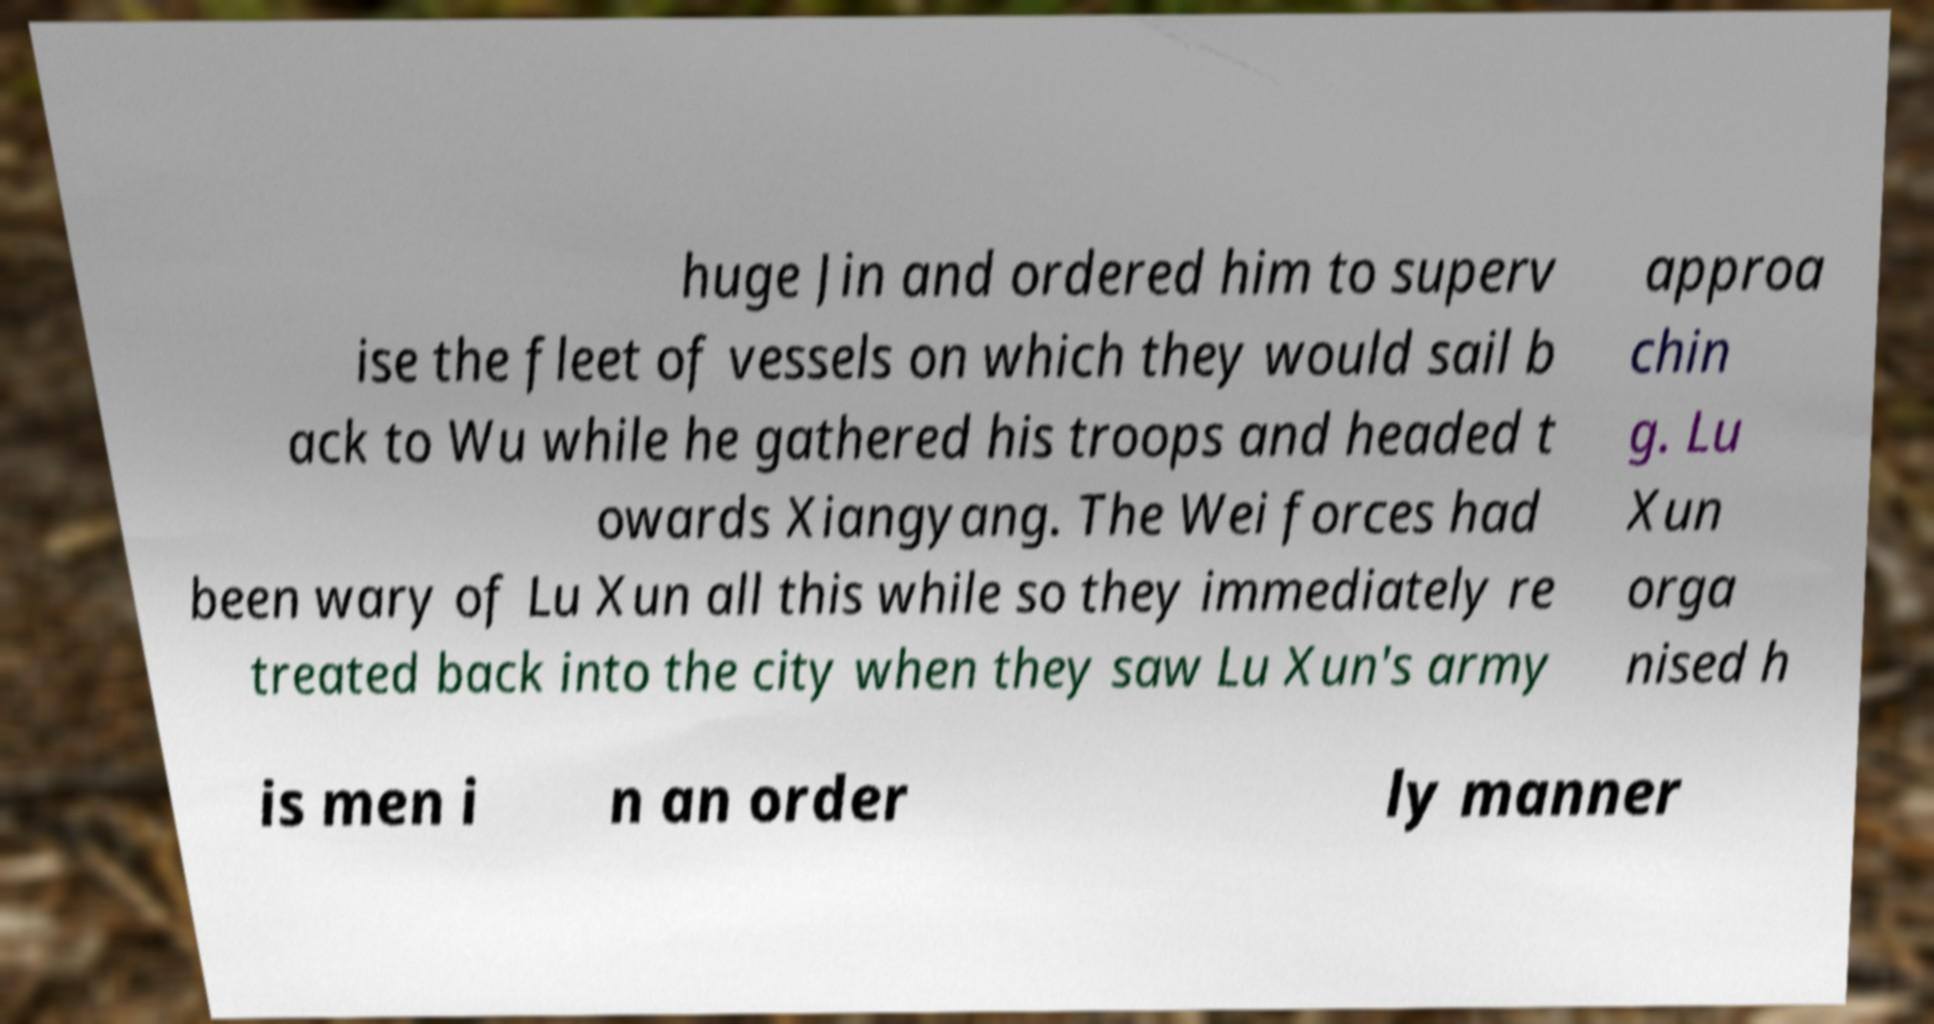Please read and relay the text visible in this image. What does it say? huge Jin and ordered him to superv ise the fleet of vessels on which they would sail b ack to Wu while he gathered his troops and headed t owards Xiangyang. The Wei forces had been wary of Lu Xun all this while so they immediately re treated back into the city when they saw Lu Xun's army approa chin g. Lu Xun orga nised h is men i n an order ly manner 